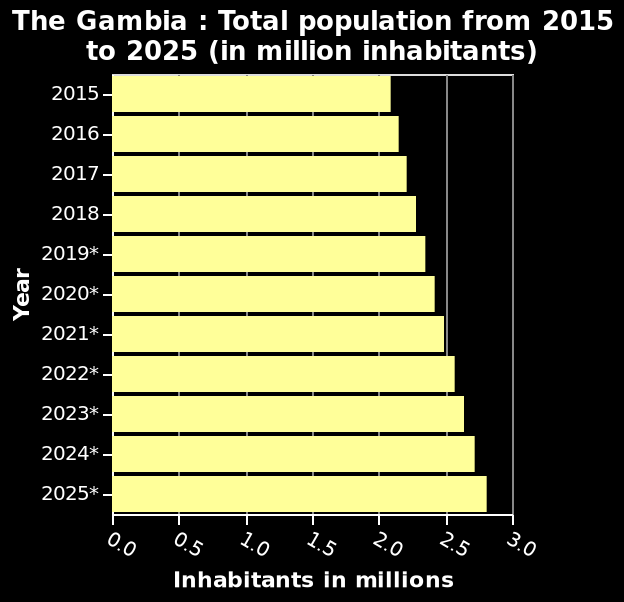<image>
Over what span of time is the predicted population increase in Gambia? The predicted population increase in Gambia is over a span of 10 years, between 2012 and 2025. please summary the statistics and relations of the chart On the chart we can see an upward tendency regarding population of Gambia. In the span of 10 years, between 2012 and 2025, it is predicted that the number of people in Gambia will increase by around 0.75 million. 